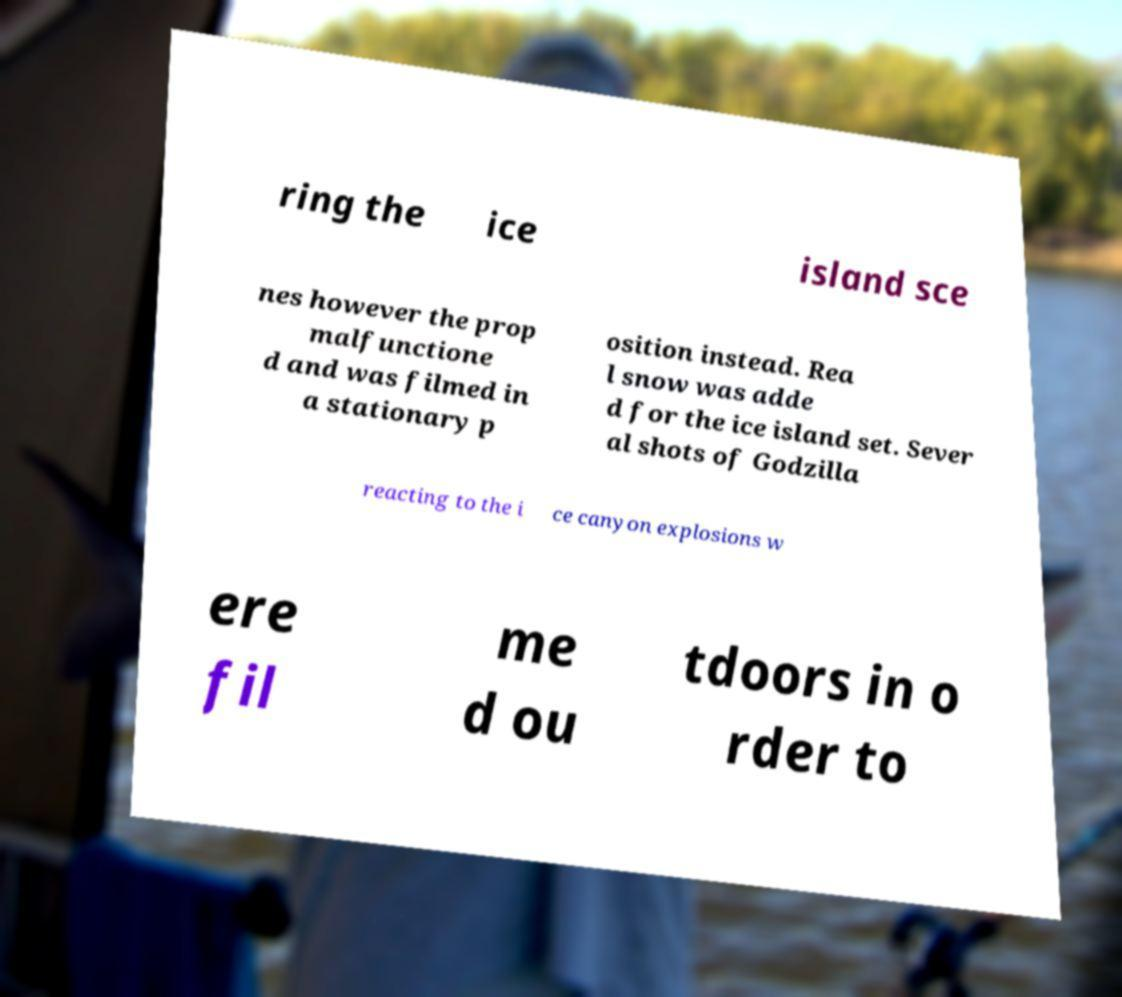I need the written content from this picture converted into text. Can you do that? ring the ice island sce nes however the prop malfunctione d and was filmed in a stationary p osition instead. Rea l snow was adde d for the ice island set. Sever al shots of Godzilla reacting to the i ce canyon explosions w ere fil me d ou tdoors in o rder to 